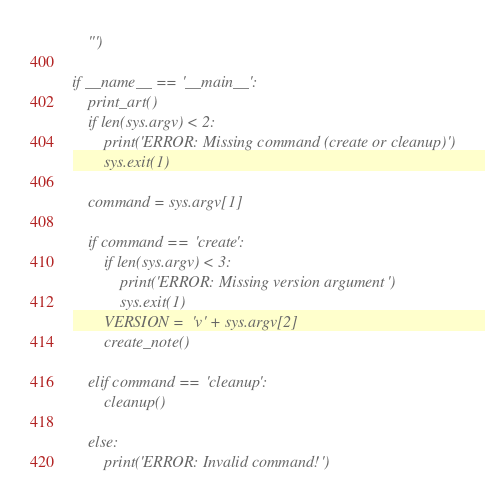<code> <loc_0><loc_0><loc_500><loc_500><_Python_>    ''')

if __name__ == '__main__':
    print_art()
    if len(sys.argv) < 2:
        print('ERROR: Missing command (create or cleanup)')
        sys.exit(1)

    command = sys.argv[1]

    if command == 'create':
        if len(sys.argv) < 3:
            print('ERROR: Missing version argument')
            sys.exit(1)
        VERSION = 'v' + sys.argv[2]
        create_note()

    elif command == 'cleanup':
        cleanup()

    else:
        print('ERROR: Invalid command!')
</code> 